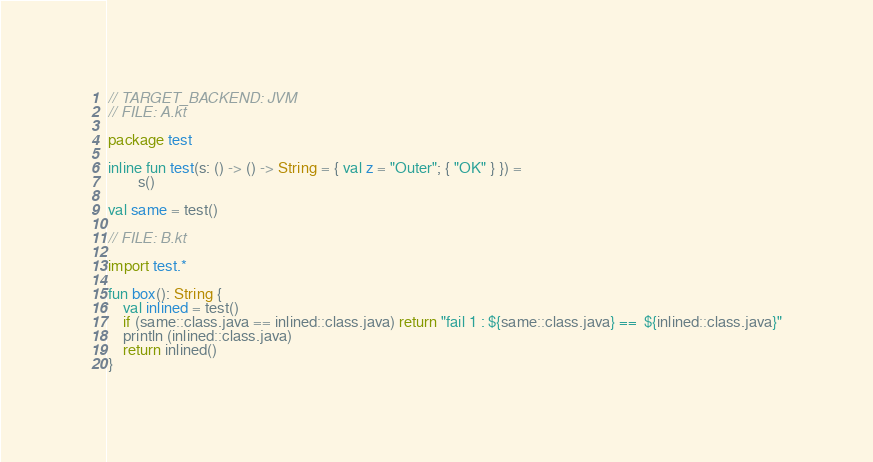Convert code to text. <code><loc_0><loc_0><loc_500><loc_500><_Kotlin_>// TARGET_BACKEND: JVM
// FILE: A.kt

package test

inline fun test(s: () -> () -> String = { val z = "Outer"; { "OK" } }) =
        s()

val same = test()

// FILE: B.kt

import test.*

fun box(): String {
    val inlined = test()
    if (same::class.java == inlined::class.java) return "fail 1 : ${same::class.java} ==  ${inlined::class.java}"
    println (inlined::class.java)
    return inlined()
}
</code> 